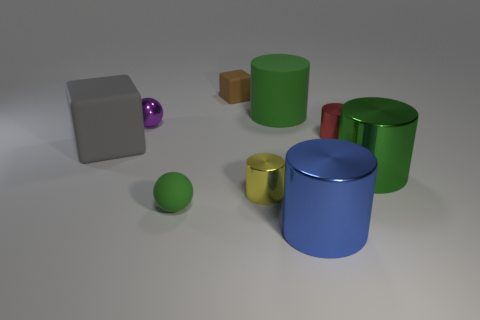Is there anything else that is made of the same material as the small green sphere?
Your response must be concise. Yes. How big is the metal cylinder that is in front of the large rubber cube and on the right side of the big blue cylinder?
Give a very brief answer. Large. Is the color of the large matte thing behind the red object the same as the sphere that is in front of the large matte cube?
Give a very brief answer. Yes. What number of small matte objects are in front of the red cylinder?
Give a very brief answer. 1. Are there any gray matte blocks behind the green thing behind the red shiny cylinder right of the small purple shiny sphere?
Keep it short and to the point. No. What number of red objects have the same size as the green shiny cylinder?
Keep it short and to the point. 0. There is a ball behind the large shiny thing that is behind the big blue thing; what is its material?
Offer a terse response. Metal. What shape is the small matte object on the right side of the tiny sphere in front of the big cylinder to the right of the blue metallic cylinder?
Make the answer very short. Cube. There is a big green object that is in front of the gray rubber object; is its shape the same as the tiny yellow object on the right side of the tiny brown matte object?
Offer a very short reply. Yes. How many other things are the same material as the purple ball?
Provide a short and direct response. 4. 